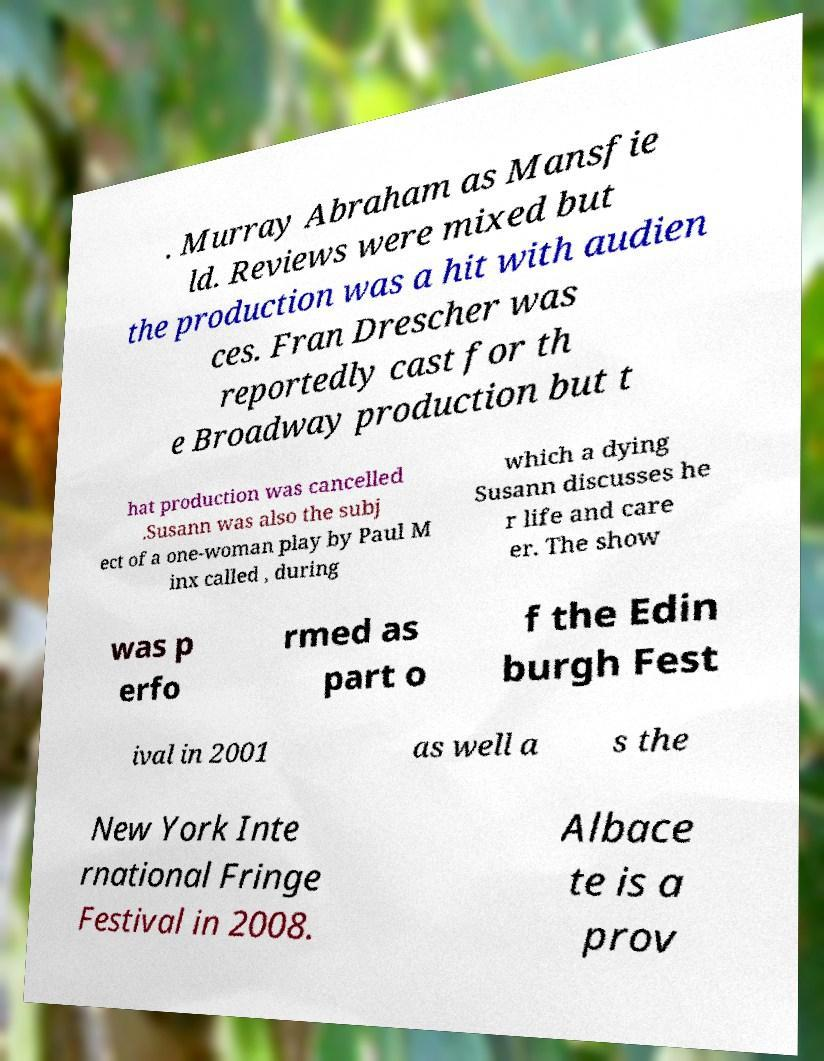Please read and relay the text visible in this image. What does it say? . Murray Abraham as Mansfie ld. Reviews were mixed but the production was a hit with audien ces. Fran Drescher was reportedly cast for th e Broadway production but t hat production was cancelled .Susann was also the subj ect of a one-woman play by Paul M inx called , during which a dying Susann discusses he r life and care er. The show was p erfo rmed as part o f the Edin burgh Fest ival in 2001 as well a s the New York Inte rnational Fringe Festival in 2008. Albace te is a prov 